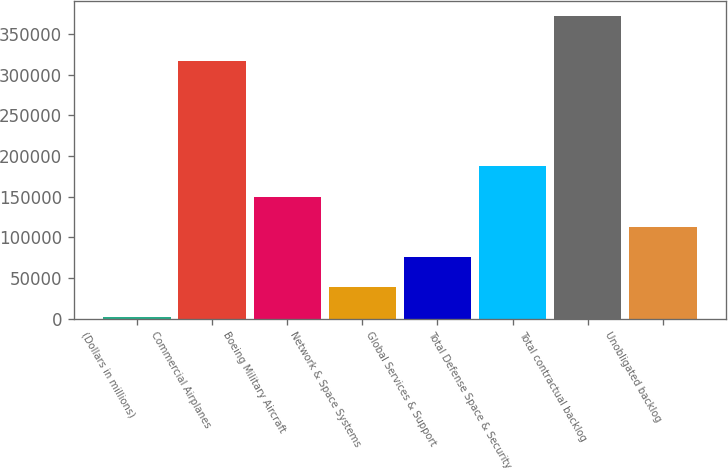Convert chart to OTSL. <chart><loc_0><loc_0><loc_500><loc_500><bar_chart><fcel>(Dollars in millions)<fcel>Commercial Airplanes<fcel>Boeing Military Aircraft<fcel>Network & Space Systems<fcel>Global Services & Support<fcel>Total Defense Space & Security<fcel>Total contractual backlog<fcel>Unobligated backlog<nl><fcel>2012<fcel>317287<fcel>150149<fcel>39046.3<fcel>76080.6<fcel>187184<fcel>372355<fcel>113115<nl></chart> 